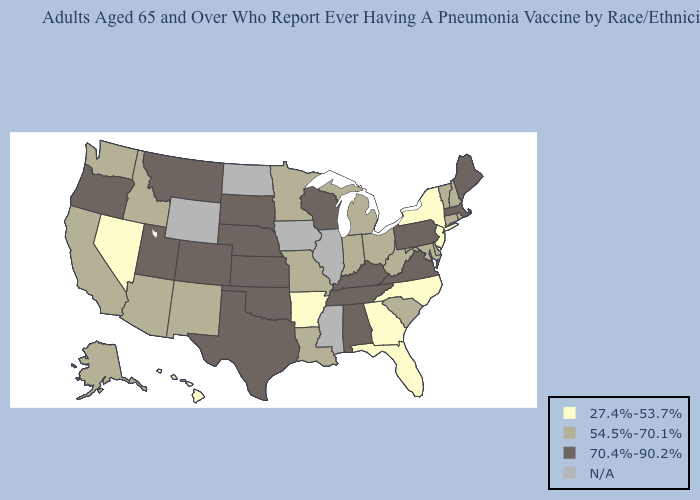Which states have the lowest value in the Northeast?
Answer briefly. New Jersey, New York. What is the highest value in the MidWest ?
Answer briefly. 70.4%-90.2%. What is the lowest value in the West?
Keep it brief. 27.4%-53.7%. Name the states that have a value in the range N/A?
Quick response, please. Illinois, Iowa, Mississippi, North Dakota, Wyoming. Name the states that have a value in the range 27.4%-53.7%?
Keep it brief. Arkansas, Florida, Georgia, Hawaii, Nevada, New Jersey, New York, North Carolina. Among the states that border Rhode Island , does Connecticut have the highest value?
Give a very brief answer. No. Name the states that have a value in the range 54.5%-70.1%?
Concise answer only. Alaska, Arizona, California, Connecticut, Delaware, Idaho, Indiana, Louisiana, Maryland, Michigan, Minnesota, Missouri, New Hampshire, New Mexico, Ohio, Rhode Island, South Carolina, Vermont, Washington, West Virginia. What is the value of Nevada?
Give a very brief answer. 27.4%-53.7%. Among the states that border Florida , which have the lowest value?
Keep it brief. Georgia. Name the states that have a value in the range 27.4%-53.7%?
Be succinct. Arkansas, Florida, Georgia, Hawaii, Nevada, New Jersey, New York, North Carolina. Name the states that have a value in the range N/A?
Concise answer only. Illinois, Iowa, Mississippi, North Dakota, Wyoming. What is the value of Massachusetts?
Short answer required. 70.4%-90.2%. Among the states that border Arkansas , does Texas have the highest value?
Short answer required. Yes. What is the value of Michigan?
Quick response, please. 54.5%-70.1%. 